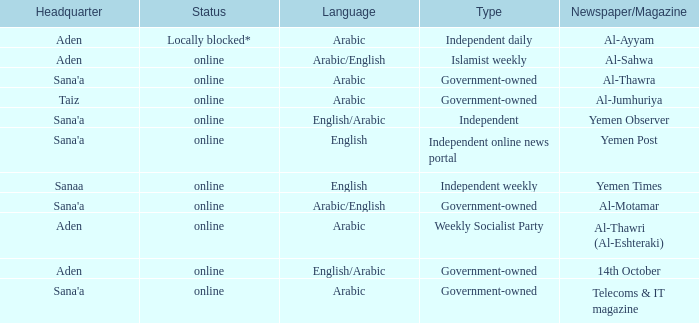What does the status indicate when the newspaper/magazine is al-thawra? Online. 